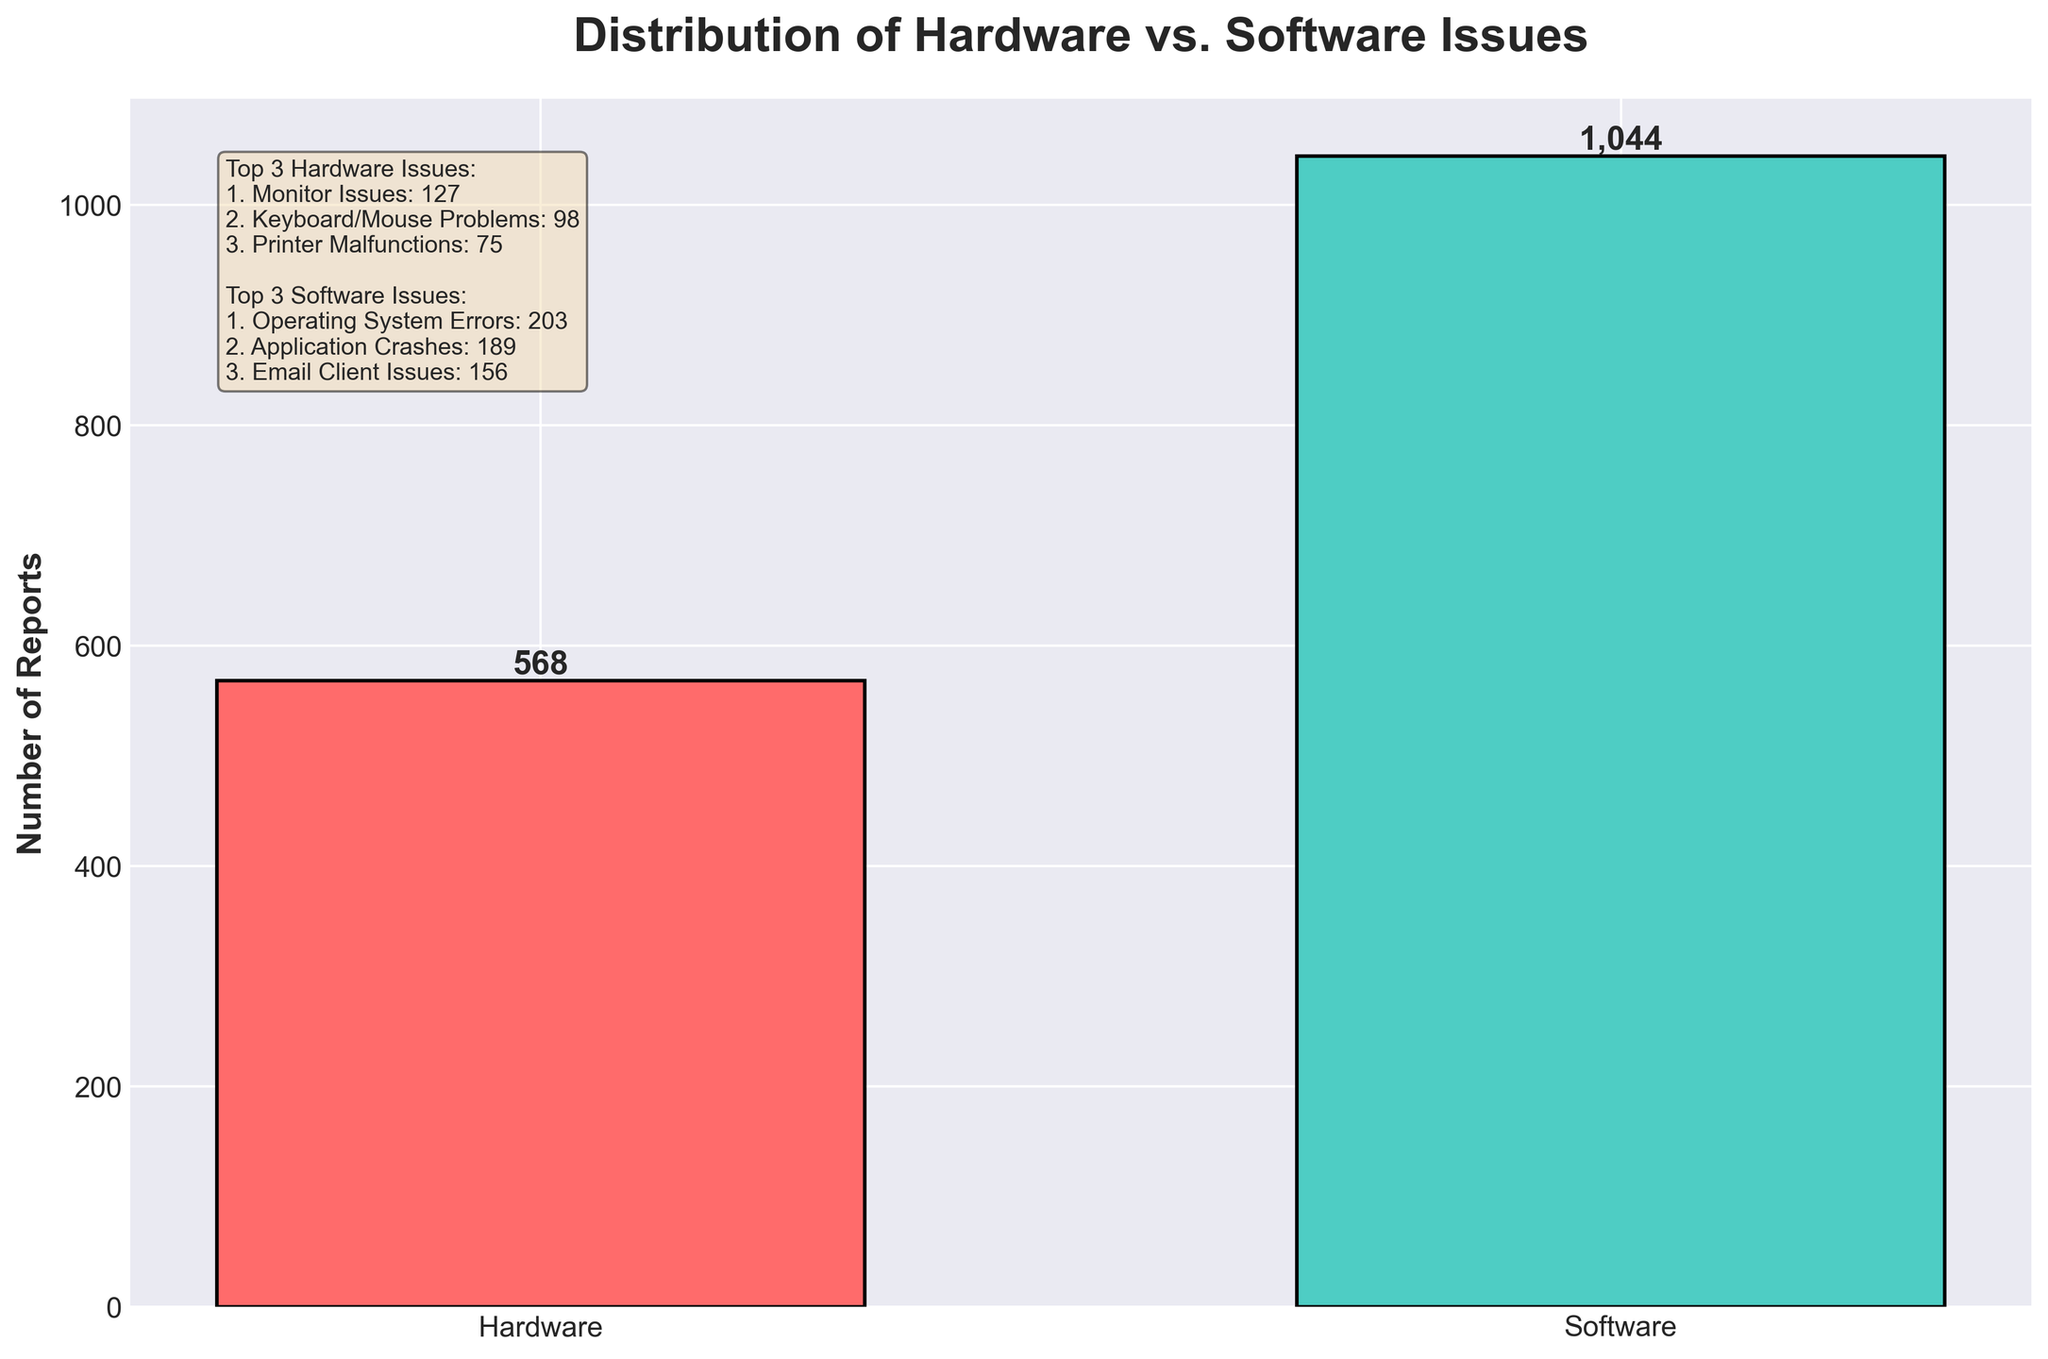Which issue type had more reports, hardware or software? From the figure, we can see that the bar for software issues is higher than the bar for hardware issues. Thus, there are more reports for software issues.
Answer: Software Which specific hardware issue had the highest number of reports? Referring to the text box in the figure, the hardware issue with the highest number of reports is "Monitor Issues" with 127 reports.
Answer: Monitor Issues What is the total number of hardware issue reports? From the figure's bar representing hardware, we can see the value is 568 (as labeled on top of the bar).
Answer: 568 How do the total software issue reports compare to hardware issue reports? The figure shows the bar for software issues is higher, labeled as 1044, and the hardware issue bar is labeled as 568. Thus, software issue reports are greater.
Answer: Software issue reports are greater What is the difference between the total number of hardware and software issue reports? From the figure: Software issue reports = 1044, Hardware issue reports = 568. Difference = 1044 - 568 = 476.
Answer: 476 What is the second most common software issue reported? According to the text box in the figure, the second most common software issue is "Application Crashes" with 189 reports.
Answer: Application Crashes How does the number of printer malfunctions compare to email client issues? The figure shows printer malfunctions have 75 reports, while email client issues have 156 reports. Hence, email client issues are greater.
Answer: Email client issues are greater What visual differences indicate which issue type had fewer total reports? The hardware bar is shorter than the software bar, indicating fewer total reports for hardware issues.
Answer: Hardware issues Which issue between hardware network connectivity and software VPN connection has more reports? From the figure, hardware network connectivity has 112 reports and software VPN connection has 105 reports. Thus, hardware network connectivity has more reports.
Answer: Hardware network connectivity Among hardware issues, what is the least frequently reported problem? The text box in the figure shows that the least reported hardware issue is "Server Hardware Failures" with 41 reports.
Answer: Server Hardware Failures 